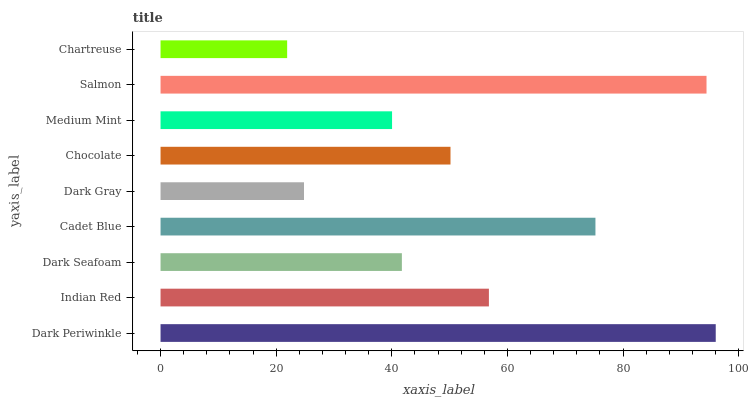Is Chartreuse the minimum?
Answer yes or no. Yes. Is Dark Periwinkle the maximum?
Answer yes or no. Yes. Is Indian Red the minimum?
Answer yes or no. No. Is Indian Red the maximum?
Answer yes or no. No. Is Dark Periwinkle greater than Indian Red?
Answer yes or no. Yes. Is Indian Red less than Dark Periwinkle?
Answer yes or no. Yes. Is Indian Red greater than Dark Periwinkle?
Answer yes or no. No. Is Dark Periwinkle less than Indian Red?
Answer yes or no. No. Is Chocolate the high median?
Answer yes or no. Yes. Is Chocolate the low median?
Answer yes or no. Yes. Is Indian Red the high median?
Answer yes or no. No. Is Dark Seafoam the low median?
Answer yes or no. No. 